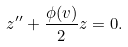<formula> <loc_0><loc_0><loc_500><loc_500>z ^ { \prime \prime } + \frac { \phi ( v ) } { 2 } z = 0 .</formula> 